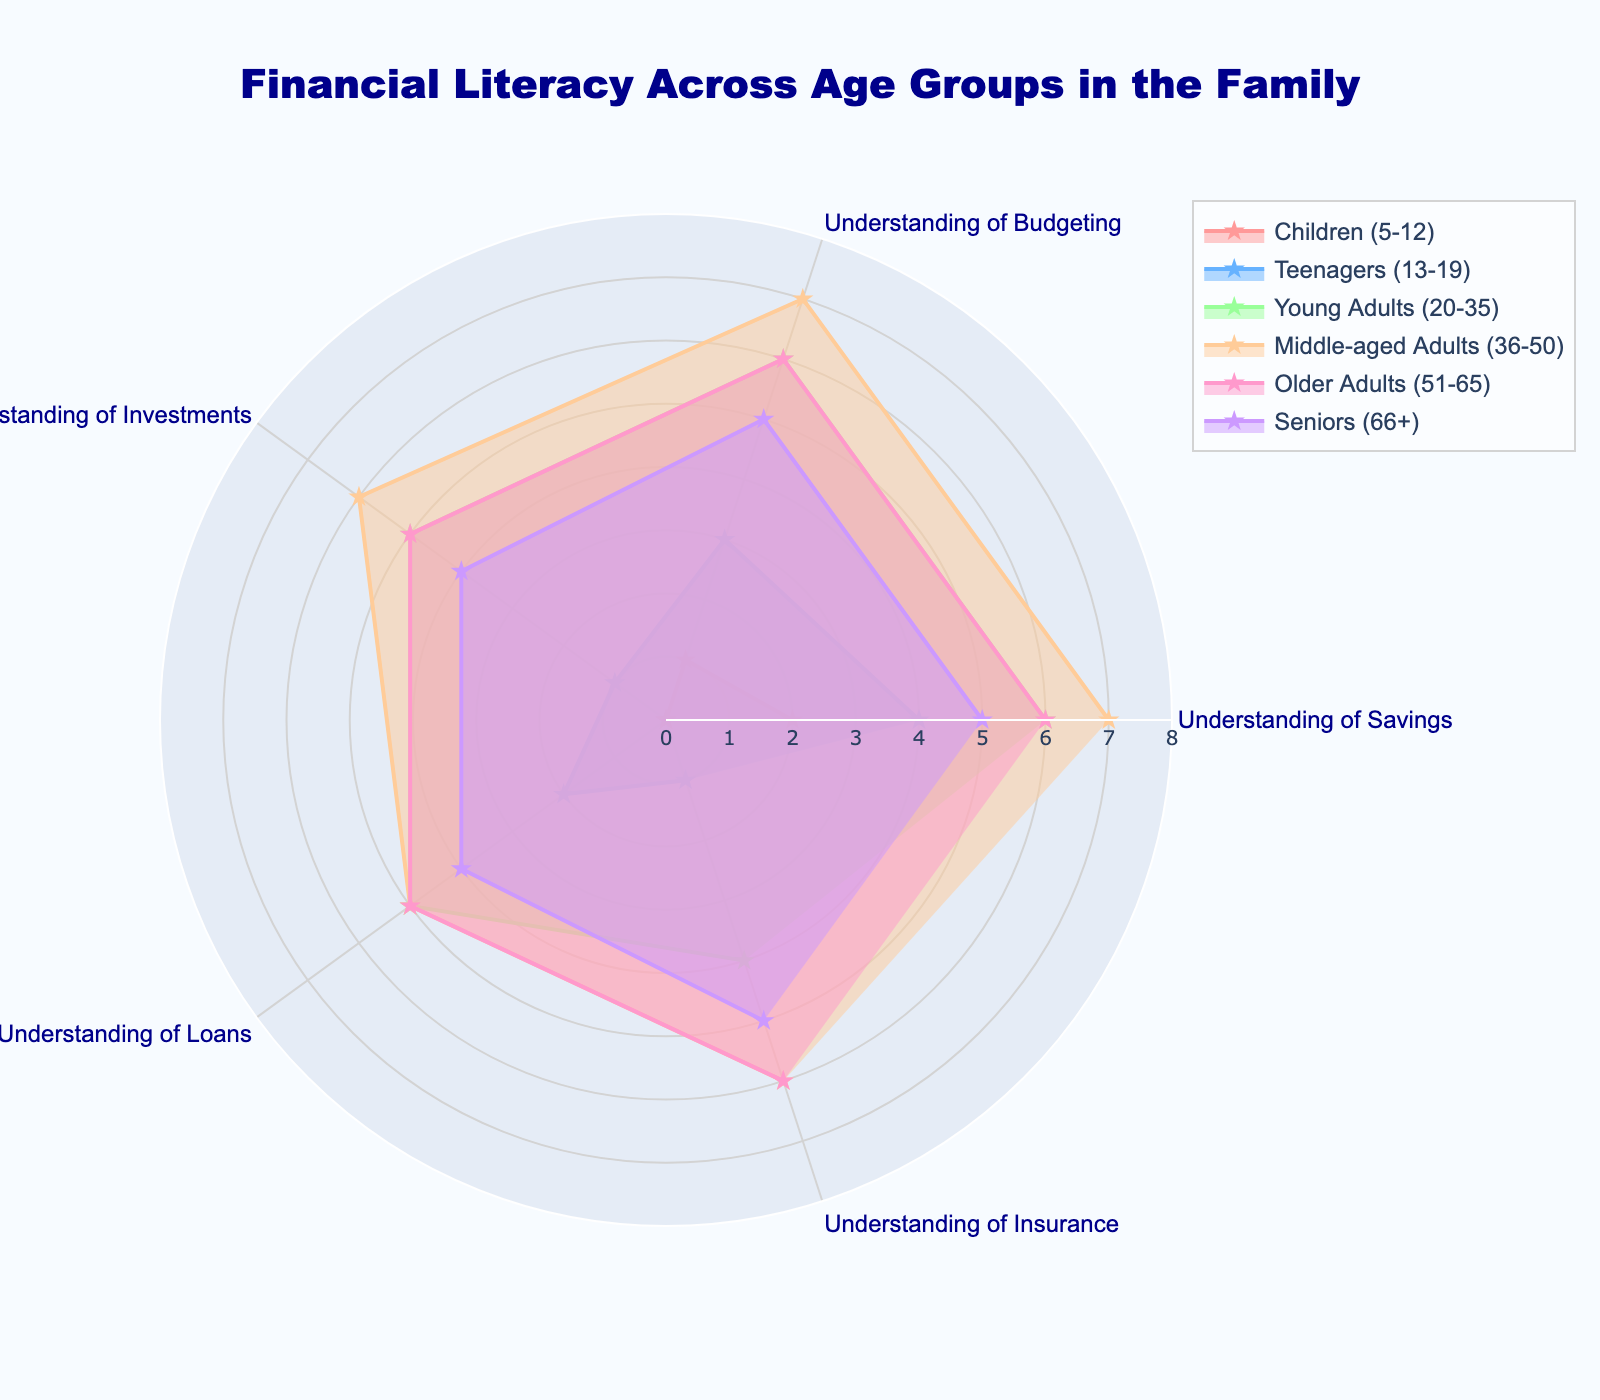How many age groups are included in the radar chart? The radar chart includes 6 distinct age groups, which are named as Children, Teenagers, Young Adults, Middle-aged Adults, Older Adults, and Seniors.
Answer: 6 What is the overall trend in understanding of savings across the age groups? By examining each age group's data, it's evident that the understanding of savings generally increases from Children to Middle-aged Adults and then declines slightly but remains relatively high for Older Adults and Seniors.
Answer: Increases then slightly declines Which age group has the highest understanding of investments? The radar chart shows that Middle-aged Adults have the highest understanding of investments with a value of 6.
Answer: Middle-aged Adults Compare the understanding of loans between Teenagers and Young Adults. Teenagers have a value of 2 for understanding loans, while Young Adults have a value of 5. Therefore, Young Adults have a higher understanding compared to Teenagers.
Answer: Young Adults Is the understanding of insurance higher for Older Adults or Seniors? For Older Adults, the understanding of insurance is represented by a value of 6, while for Seniors, it is represented by a value of 5. Hence, Older Adults have a higher understanding.
Answer: Older Adults Which age group shows the least understanding of all financial aspects (savings, budgeting, investments, loans, and insurance)? Children have the lowest values across all financial aspects, ranging from 0 to 2.
Answer: Children Determine the average level of understanding of budgeting for Middle-aged Adults. The radar chart provides a value of 7 for Middle-aged Adults' understanding of budgeting, which is the single data point, so the average is simply 7.
Answer: 7 How does the understanding of savings change between Young Adults and Middle-aged Adults? Young Adults have a savings understanding value of 6, while Middle-aged Adults have a value of 7. So, there is an increase from 6 to 7, which is a difference of 1.
Answer: Increases by 1 Sum the values of understanding of investments across all age groups. The values for understanding of investments are: 0 (Children), 1 (Teenagers), 5 (Young Adults), 6 (Middle-aged Adults), 5 (Older Adults), and 4 (Seniors). Summing these up: 0 + 1 + 5 + 6 + 5 + 4 = 21.
Answer: 21 What is the overall pattern seen in the radar chart regarding financial literacy from Children to Seniors? The radar chart shows that financial literacy generally increases with age, peaking around Middle-aged Adults, and slightly declines but remains robust in Older Adults and Seniors.
Answer: Increases, peaks, then slightly declines 